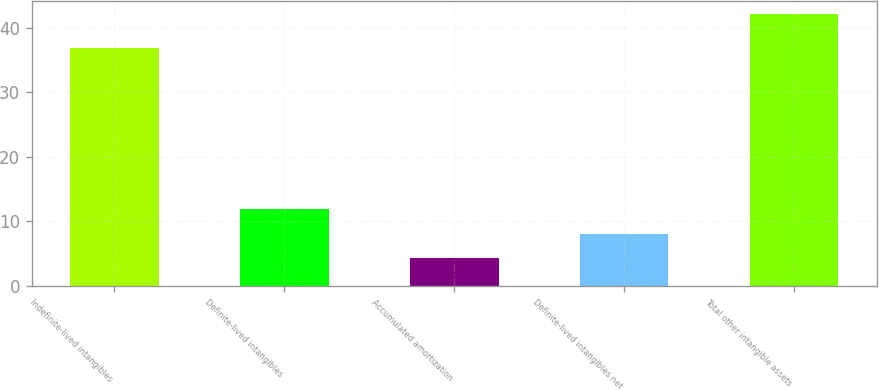<chart> <loc_0><loc_0><loc_500><loc_500><bar_chart><fcel>Indefinite-lived intangibles<fcel>Definite-lived intangibles<fcel>Accumulated amortization<fcel>Definite-lived intangibles net<fcel>Total other intangible assets<nl><fcel>36.9<fcel>11.86<fcel>4.3<fcel>8.08<fcel>42.1<nl></chart> 